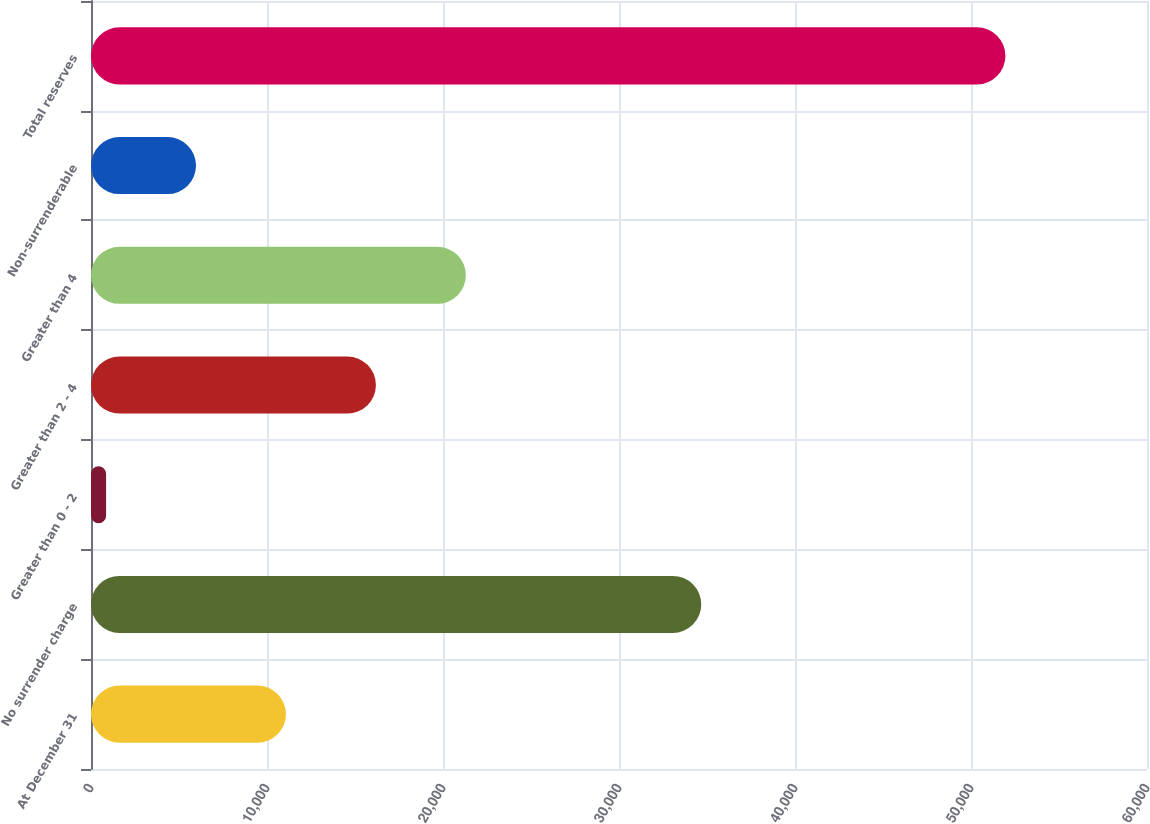<chart> <loc_0><loc_0><loc_500><loc_500><bar_chart><fcel>At December 31<fcel>No surrender charge<fcel>Greater than 0 - 2<fcel>Greater than 2 - 4<fcel>Greater than 4<fcel>Non-surrenderable<fcel>Total reserves<nl><fcel>11077<fcel>34674<fcel>857<fcel>16187<fcel>21297<fcel>5967<fcel>51957<nl></chart> 